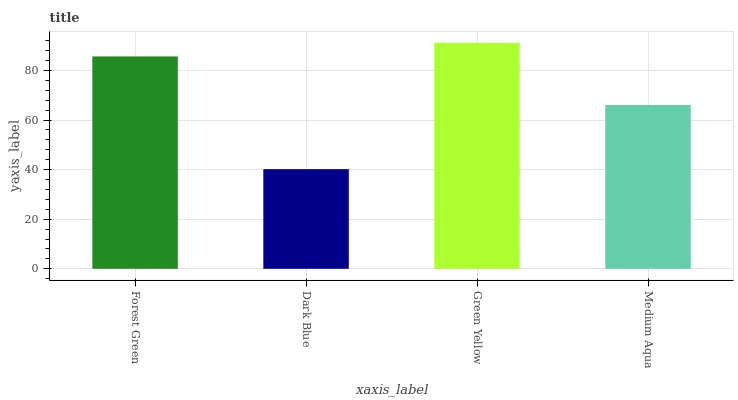Is Green Yellow the minimum?
Answer yes or no. No. Is Dark Blue the maximum?
Answer yes or no. No. Is Green Yellow greater than Dark Blue?
Answer yes or no. Yes. Is Dark Blue less than Green Yellow?
Answer yes or no. Yes. Is Dark Blue greater than Green Yellow?
Answer yes or no. No. Is Green Yellow less than Dark Blue?
Answer yes or no. No. Is Forest Green the high median?
Answer yes or no. Yes. Is Medium Aqua the low median?
Answer yes or no. Yes. Is Medium Aqua the high median?
Answer yes or no. No. Is Green Yellow the low median?
Answer yes or no. No. 